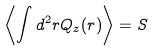Convert formula to latex. <formula><loc_0><loc_0><loc_500><loc_500>\left \langle \int d ^ { 2 } r Q _ { z } ( r ) \right \rangle = S</formula> 